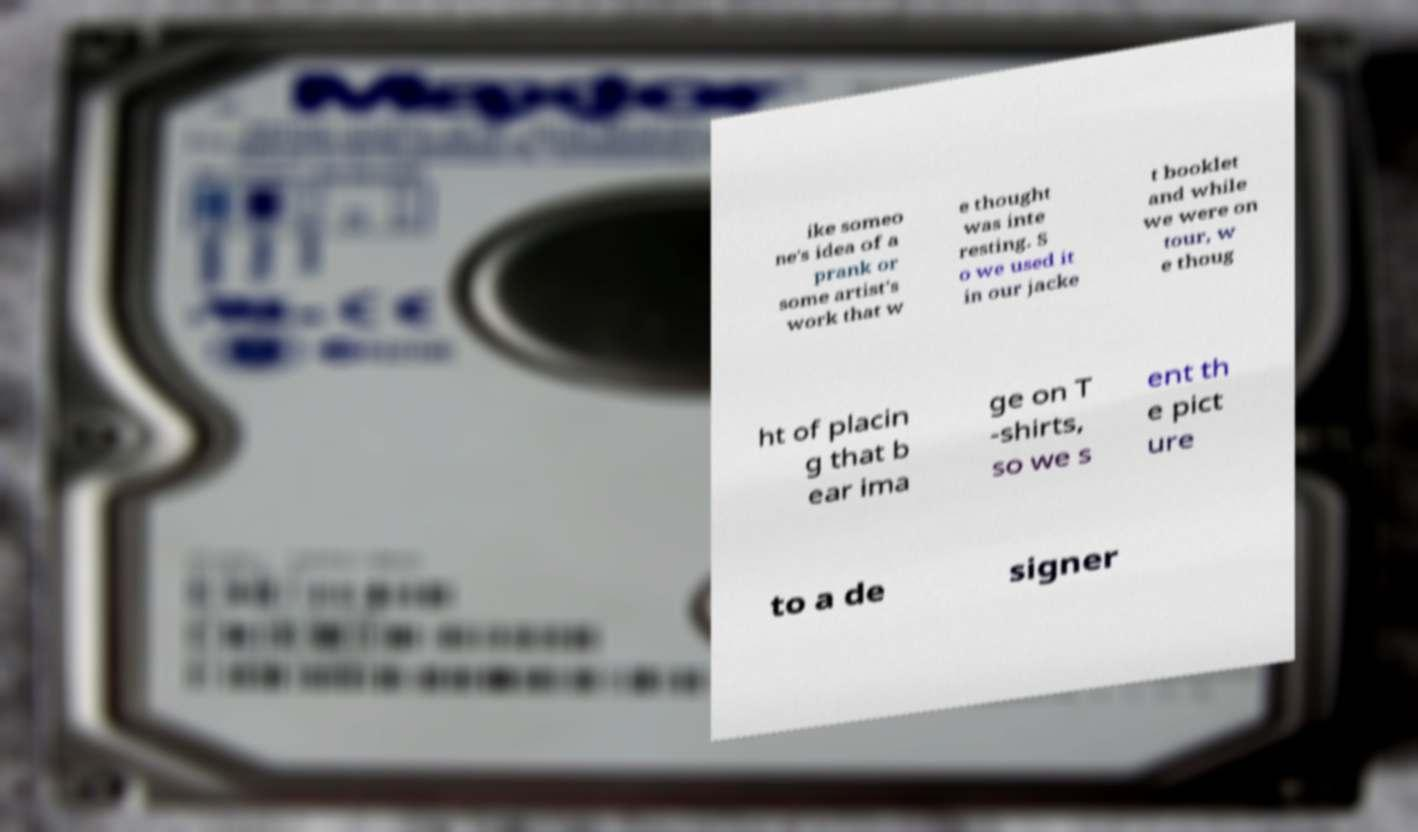Can you accurately transcribe the text from the provided image for me? ike someo ne's idea of a prank or some artist's work that w e thought was inte resting. S o we used it in our jacke t booklet and while we were on tour, w e thoug ht of placin g that b ear ima ge on T -shirts, so we s ent th e pict ure to a de signer 